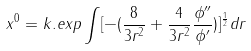<formula> <loc_0><loc_0><loc_500><loc_500>x ^ { 0 } = k . e x p \int [ - ( \frac { 8 } { 3 r ^ { 2 } } + \frac { 4 } { 3 r ^ { 2 } } \frac { \phi ^ { \prime \prime } } { \phi ^ { \prime } } ) ] ^ { \frac { 1 } { 2 } } d r</formula> 